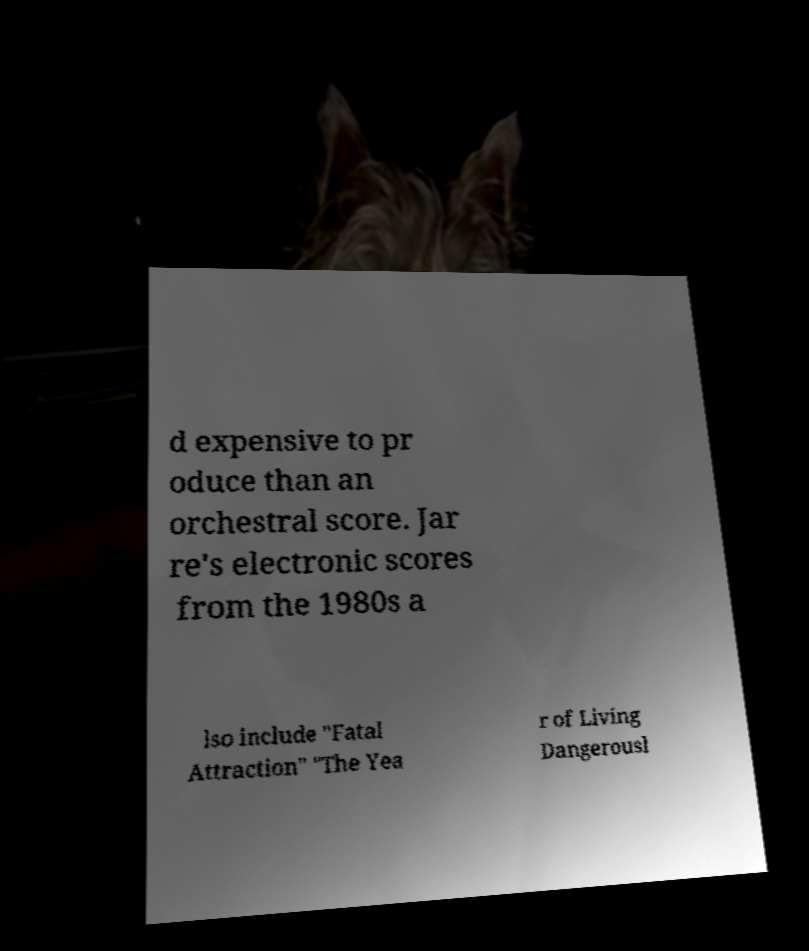There's text embedded in this image that I need extracted. Can you transcribe it verbatim? d expensive to pr oduce than an orchestral score. Jar re's electronic scores from the 1980s a lso include "Fatal Attraction" "The Yea r of Living Dangerousl 